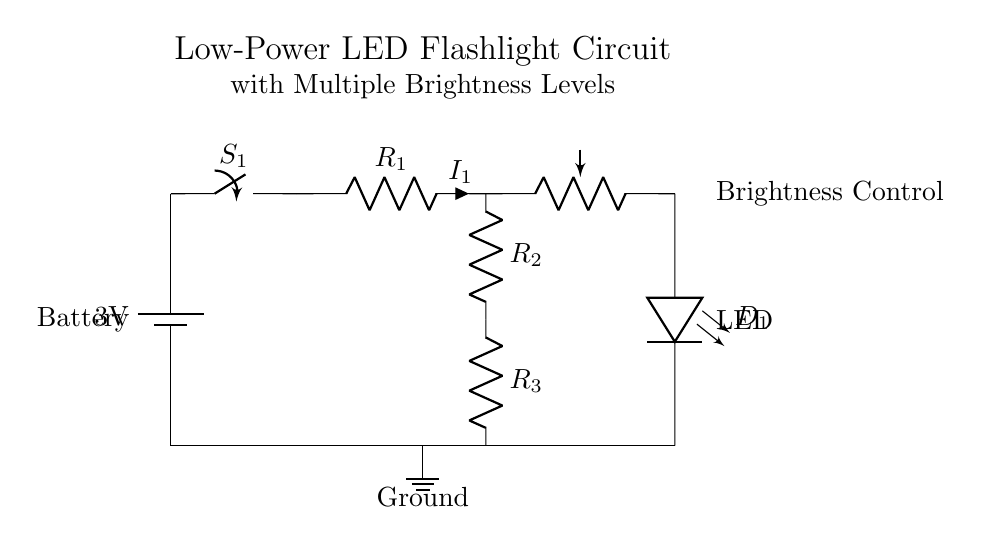What type of battery is used in this circuit? The battery is labeled as a 3V battery, indicating its voltage rating.
Answer: 3V What is the role of the switch in this circuit? The switch (S1) is used to open or close the circuit, allowing control over whether the flashlight is on or off.
Answer: Control What does the potentiometer control? The potentiometer adjusts the brightness of the LED by varying the resistance in the circuit.
Answer: Brightness How many resistors are present in this circuit? The circuit shows three resistors labeled R1, R2, and R3 connected in series.
Answer: Three What is the purpose of the LED in this design? The LED serves as the light source for the flashlight, illuminating when the circuit is complete.
Answer: Light source What are the connections of the ground in this circuit? The ground is connected to the negative terminal of the battery and all components share a common ground return at the bottom.
Answer: Common ground How does changing the resistance of the potentiometer affect the circuit? Increasing the resistance of the potentiometer reduces current flow to the LED, resulting in lower brightness, while decreasing resistance increases brightness.
Answer: Adjusts brightness 